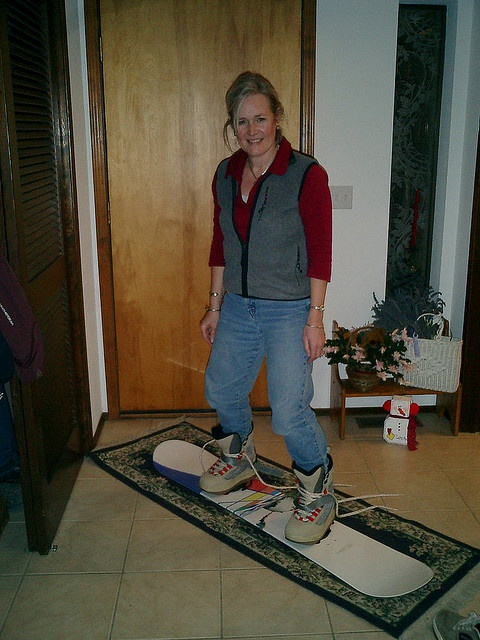Describe the objects in this image and their specific colors. I can see people in black, gray, blue, and maroon tones, snowboard in black, gray, and darkgray tones, potted plant in black, gray, darkgray, and maroon tones, potted plant in black, darkgray, gray, and purple tones, and handbag in black and gray tones in this image. 